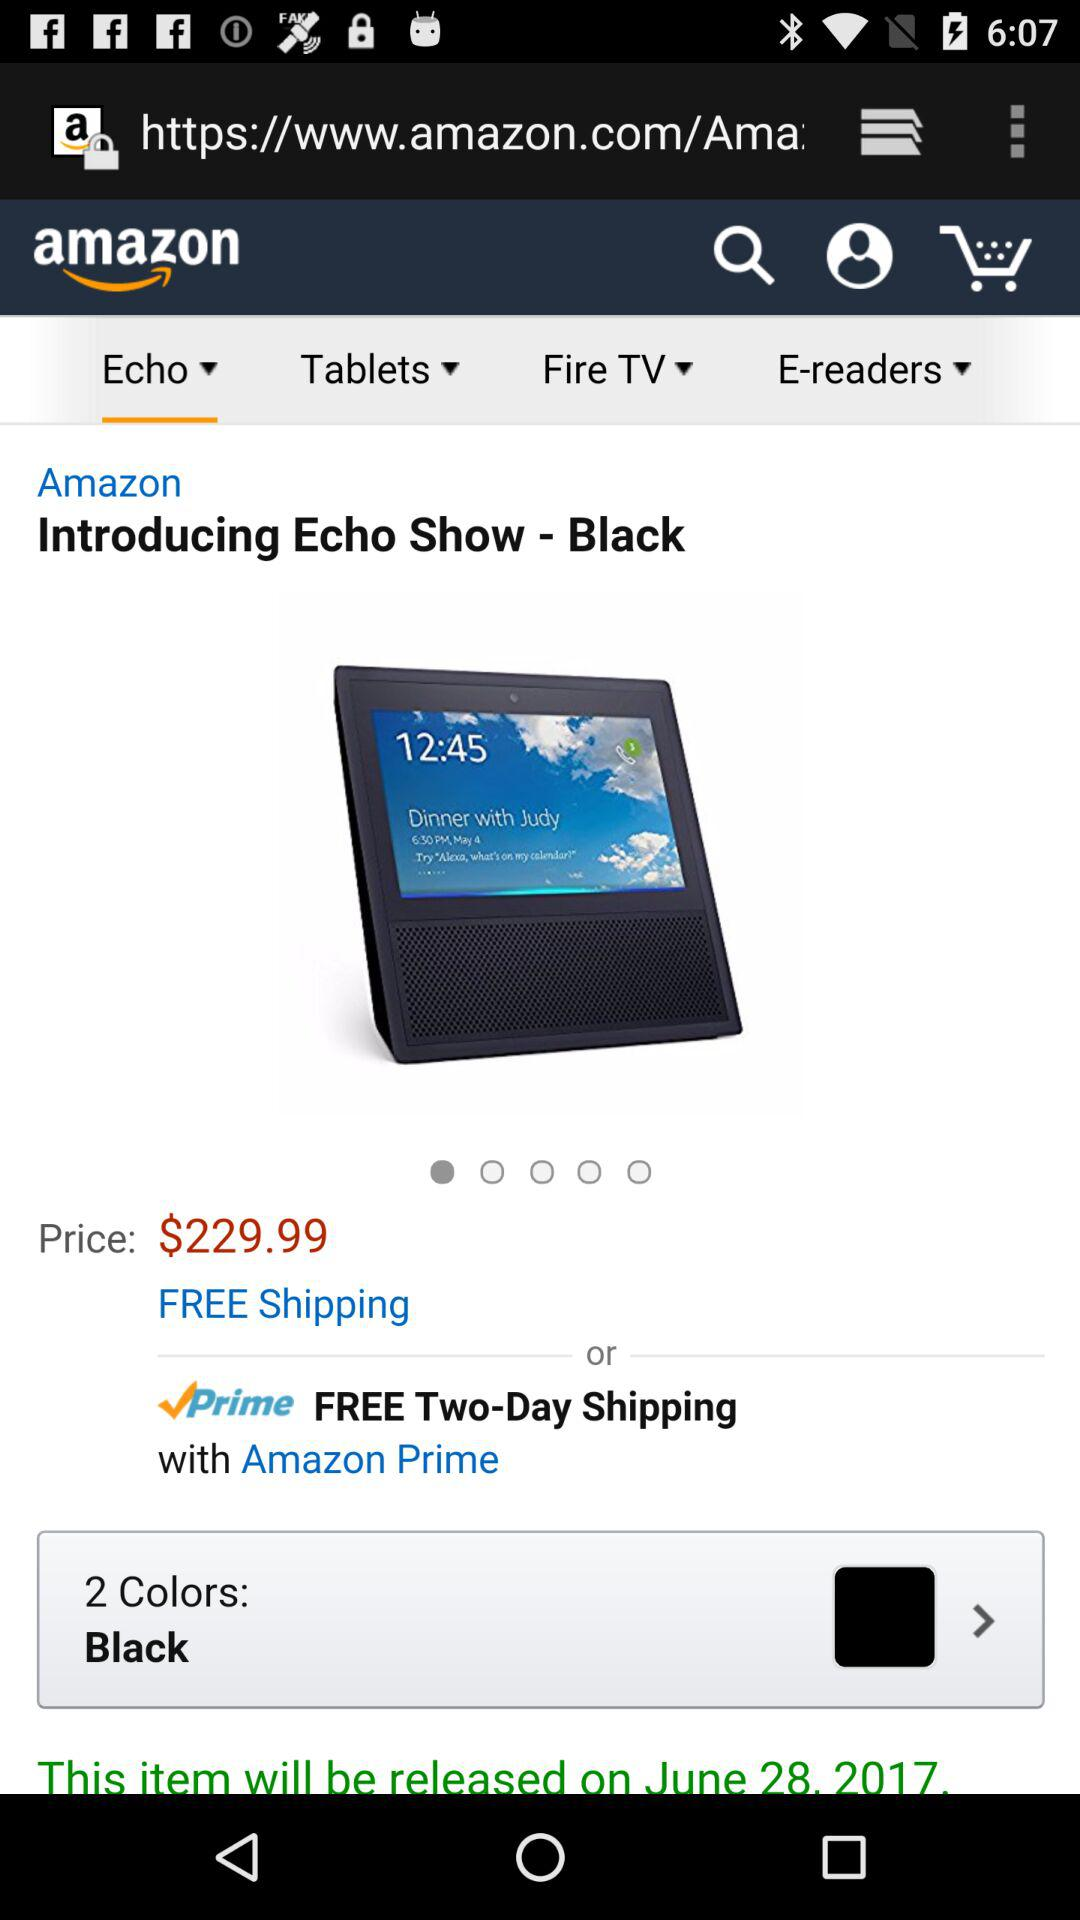What is the cost of echo show-black? The cost is $229.99. 